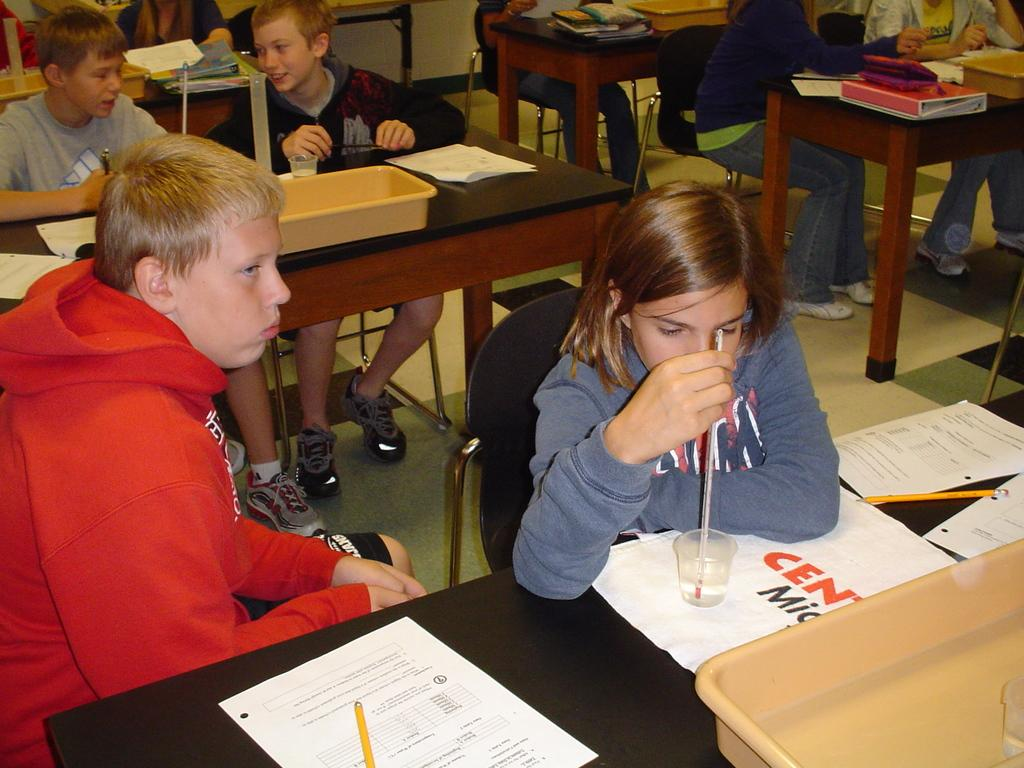What is the seating arrangement of the people in the image? The people are seated on chairs in a room. What are the chairs positioned in front of? The chairs are positioned in front of black tables. What items can be seen on the tables? There are trays, papers, pencils, and glasses on the tables. What type of range can be seen in the image? There is no range present in the image. What is being served for lunch in the image? The image does not show any food or lunch being served. 